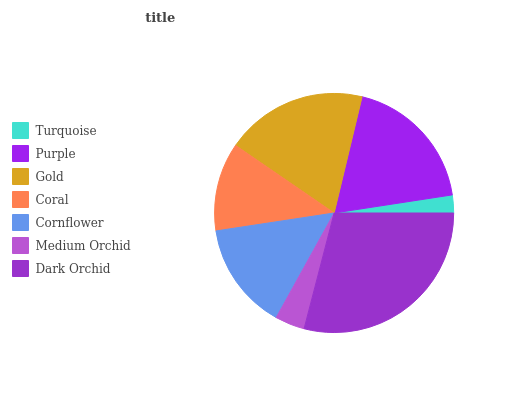Is Turquoise the minimum?
Answer yes or no. Yes. Is Dark Orchid the maximum?
Answer yes or no. Yes. Is Purple the minimum?
Answer yes or no. No. Is Purple the maximum?
Answer yes or no. No. Is Purple greater than Turquoise?
Answer yes or no. Yes. Is Turquoise less than Purple?
Answer yes or no. Yes. Is Turquoise greater than Purple?
Answer yes or no. No. Is Purple less than Turquoise?
Answer yes or no. No. Is Cornflower the high median?
Answer yes or no. Yes. Is Cornflower the low median?
Answer yes or no. Yes. Is Purple the high median?
Answer yes or no. No. Is Coral the low median?
Answer yes or no. No. 